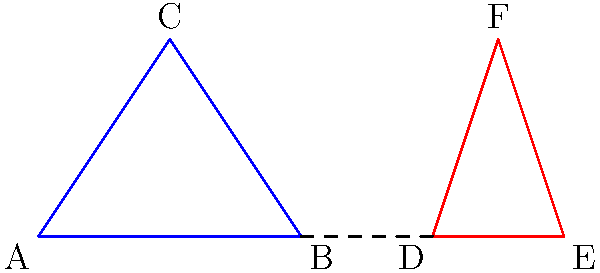In a school zone, two triangular road signs are being installed to warn drivers about children crossing. Triangle ABC represents the standard sign, while triangle DEF is a larger version for improved visibility. If AB = 4 units, DE = 6 units, and the triangles are congruent, what is the height of triangle DEF? Let's approach this step-by-step:

1) First, we need to understand what congruent means. Congruent triangles have the same shape and size, which means their corresponding angles are equal and their corresponding sides are proportional.

2) We're told that AB = 4 units and DE = 6 units. Since the triangles are congruent, we can set up a proportion:

   $\frac{DE}{AB} = \frac{6}{4} = \frac{3}{2}$

3) This ratio of 3:2 will apply to all corresponding sides of the triangles.

4) Now, let's consider the heights of the triangles. In triangle ABC, let's call the height from C to AB as h. In triangle DEF, the corresponding height from F to DE will be H.

5) We can set up another proportion:

   $\frac{H}{h} = \frac{3}{2}$

6) We don't know the value of h, but we don't need to. We just need to find H in terms of h.

7) From the proportion, we can say:

   $H = \frac{3}{2}h$

8) Now, let's consider the areas of the triangles. The area of a triangle is $\frac{1}{2} * base * height$

9) For triangle ABC: Area = $\frac{1}{2} * 4 * h = 2h$
   For triangle DEF: Area = $\frac{1}{2} * 6 * H = 3H$

10) Since the triangles are congruent, their areas must be equal:

    $2h = 3H$

11) Substituting what we know about H:

    $2h = 3(\frac{3}{2}h)$
    $2h = \frac{9}{2}h$

12) This equation is always true, which confirms our earlier calculation that H = $\frac{3}{2}h$

Therefore, the height of triangle DEF is 1.5 times the height of triangle ABC.
Answer: $\frac{3}{2}$ times the height of ABC 